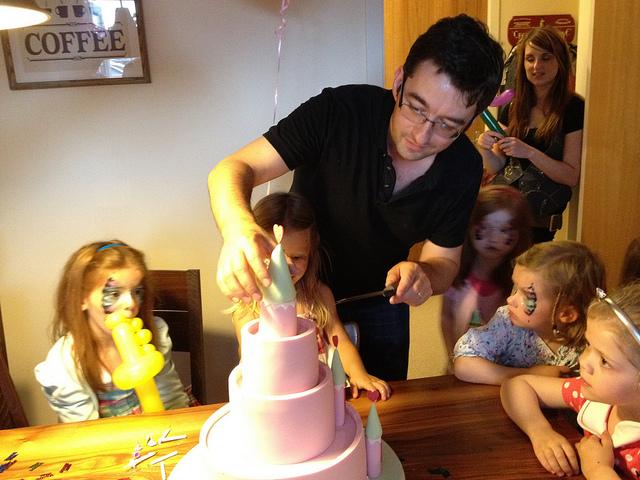Is this a wedding party?
Be succinct. No. What color is the cake?
Quick response, please. Pink. How many men are in this picture?
Concise answer only. 1. How many kids in the picture?
Answer briefly. 5. 